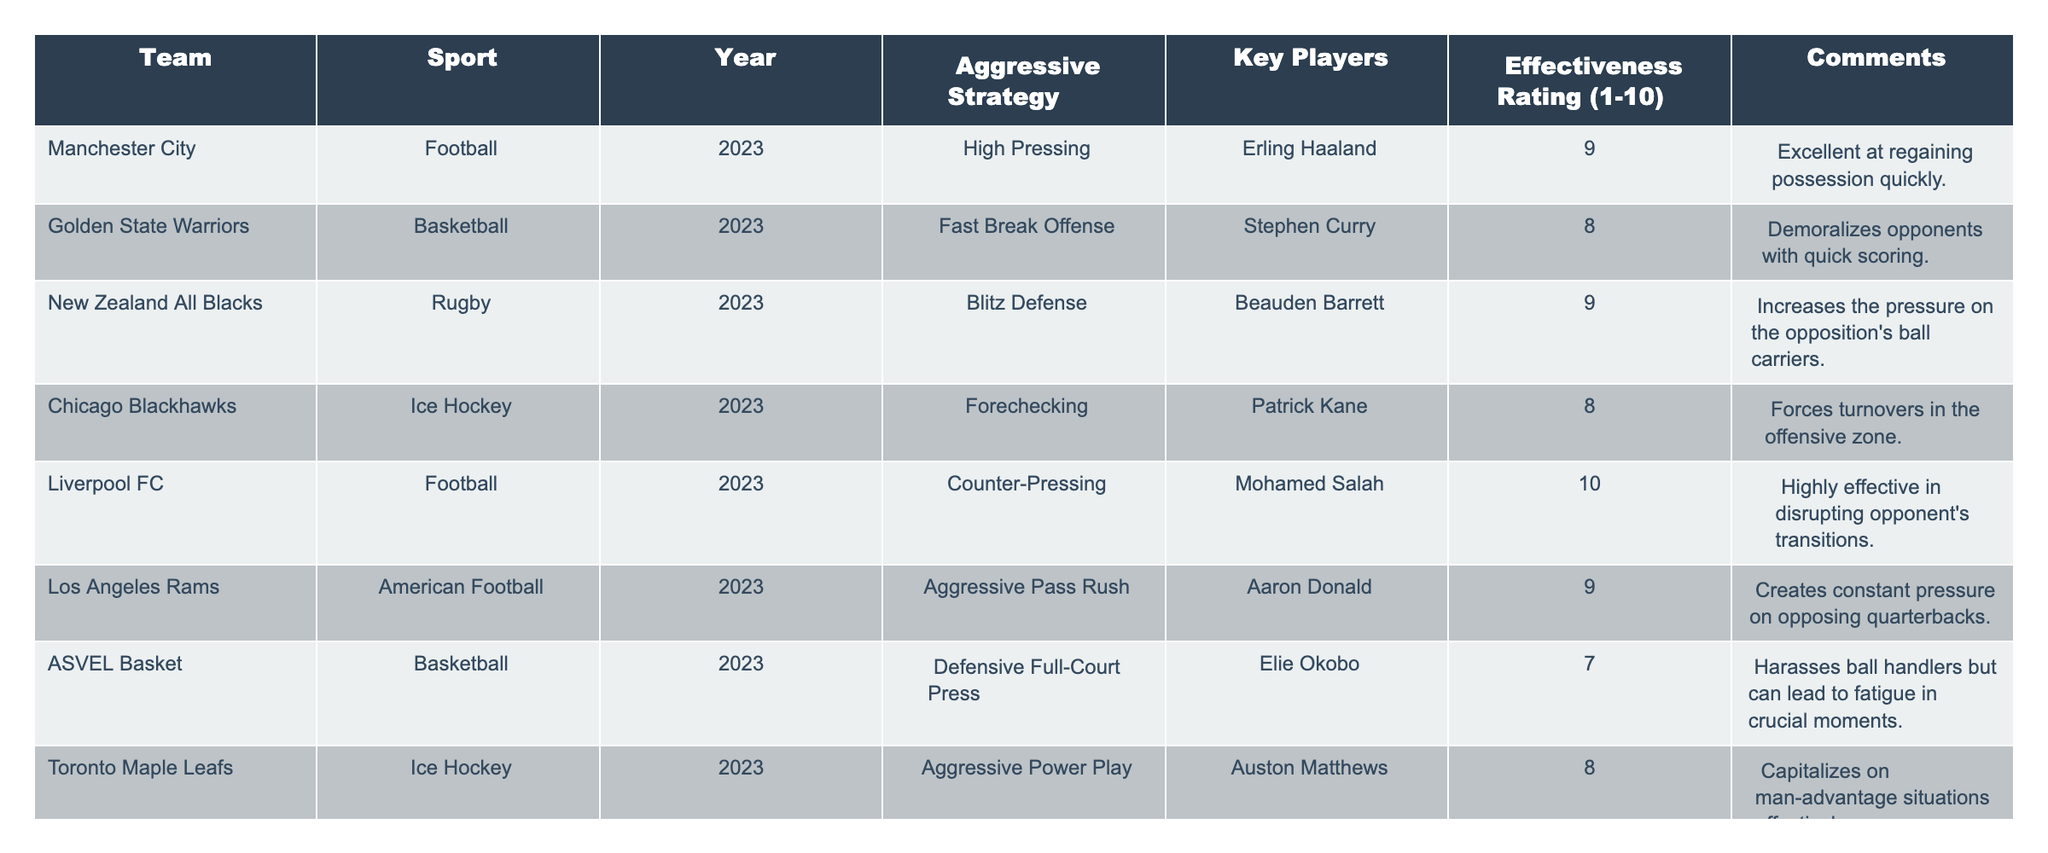What aggressive strategy does Liverpool FC use? The table lists Liverpool FC along with their aggressive strategy, which is "Counter-Pressing."
Answer: Counter-Pressing Which sport has the highest effectiveness rating among the teams listed? The table shows Liverpool FC with an effectiveness rating of 10, which is the highest among all teams.
Answer: Football How many teams have an effectiveness rating of 8 or higher? By counting the effectiveness ratings of teams listed in the table, we find that there are five teams with ratings of 8 or higher: Manchester City, Golden State Warriors, New Zealand All Blacks, Liverpool FC, and Los Angeles Rams.
Answer: Five Is the aggressive strategy used by the Chicago Blackhawks more effective than that of ASVEL Basket? The effectiveness rating for the Chicago Blackhawks is 8 and for ASVEL Basket is 7, so yes, the strategy of the Chicago Blackhawks is more effective.
Answer: Yes What is the average effectiveness rating of the teams that use a "fast" strategy? The teams that use a fast strategy are Golden State Warriors (8, Fast Break Offense), and Liverpool FC (10, Counter-Pressing). The average is (8 + 10)/2 = 9.
Answer: 9 Which team employs a strategy that increases pressure on the opposition's ball carriers? The table mentions the New Zealand All Blacks using "Blitz Defense" to increase pressure on the opposition's ball carriers.
Answer: New Zealand All Blacks Which sport do both Liverpool FC and Manchester City represent? Both teams are listed under the sport of Football in the table.
Answer: Football What is the difference in effectiveness ratings between the teams with the highest and lowest ratings? The highest is Liverpool FC with an effectiveness of 10, and the lowest is ASVEL Basket with an effectiveness of 7. The difference is 10 - 7 = 3.
Answer: 3 How many different sports are represented by the teams in this table? The teams in the table compete in four different sports: Football, Basketball, Rugby, and Ice Hockey.
Answer: Four Identify the team that uses aggressive passing strategy and provide its effectiveness rating. The Los Angeles Rams use "Aggressive Pass Rush" as their strategy and have an effectiveness rating of 9.
Answer: Los Angeles Rams, 9 